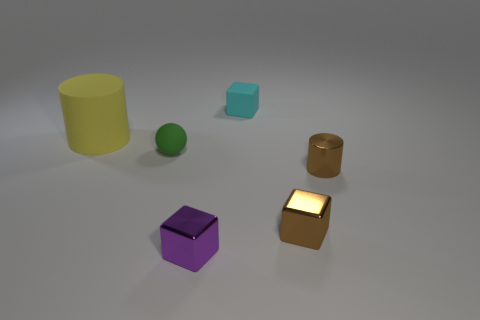Subtract all metallic cubes. How many cubes are left? 1 Add 3 small shiny cylinders. How many objects exist? 9 Subtract 2 cylinders. How many cylinders are left? 0 Subtract all cylinders. How many objects are left? 4 Subtract all yellow balls. How many blue blocks are left? 0 Subtract all purple blocks. How many blocks are left? 2 Subtract all yellow spheres. Subtract all brown blocks. How many spheres are left? 1 Subtract all large gray metallic balls. Subtract all tiny things. How many objects are left? 1 Add 3 brown things. How many brown things are left? 5 Add 1 small cyan metallic things. How many small cyan metallic things exist? 1 